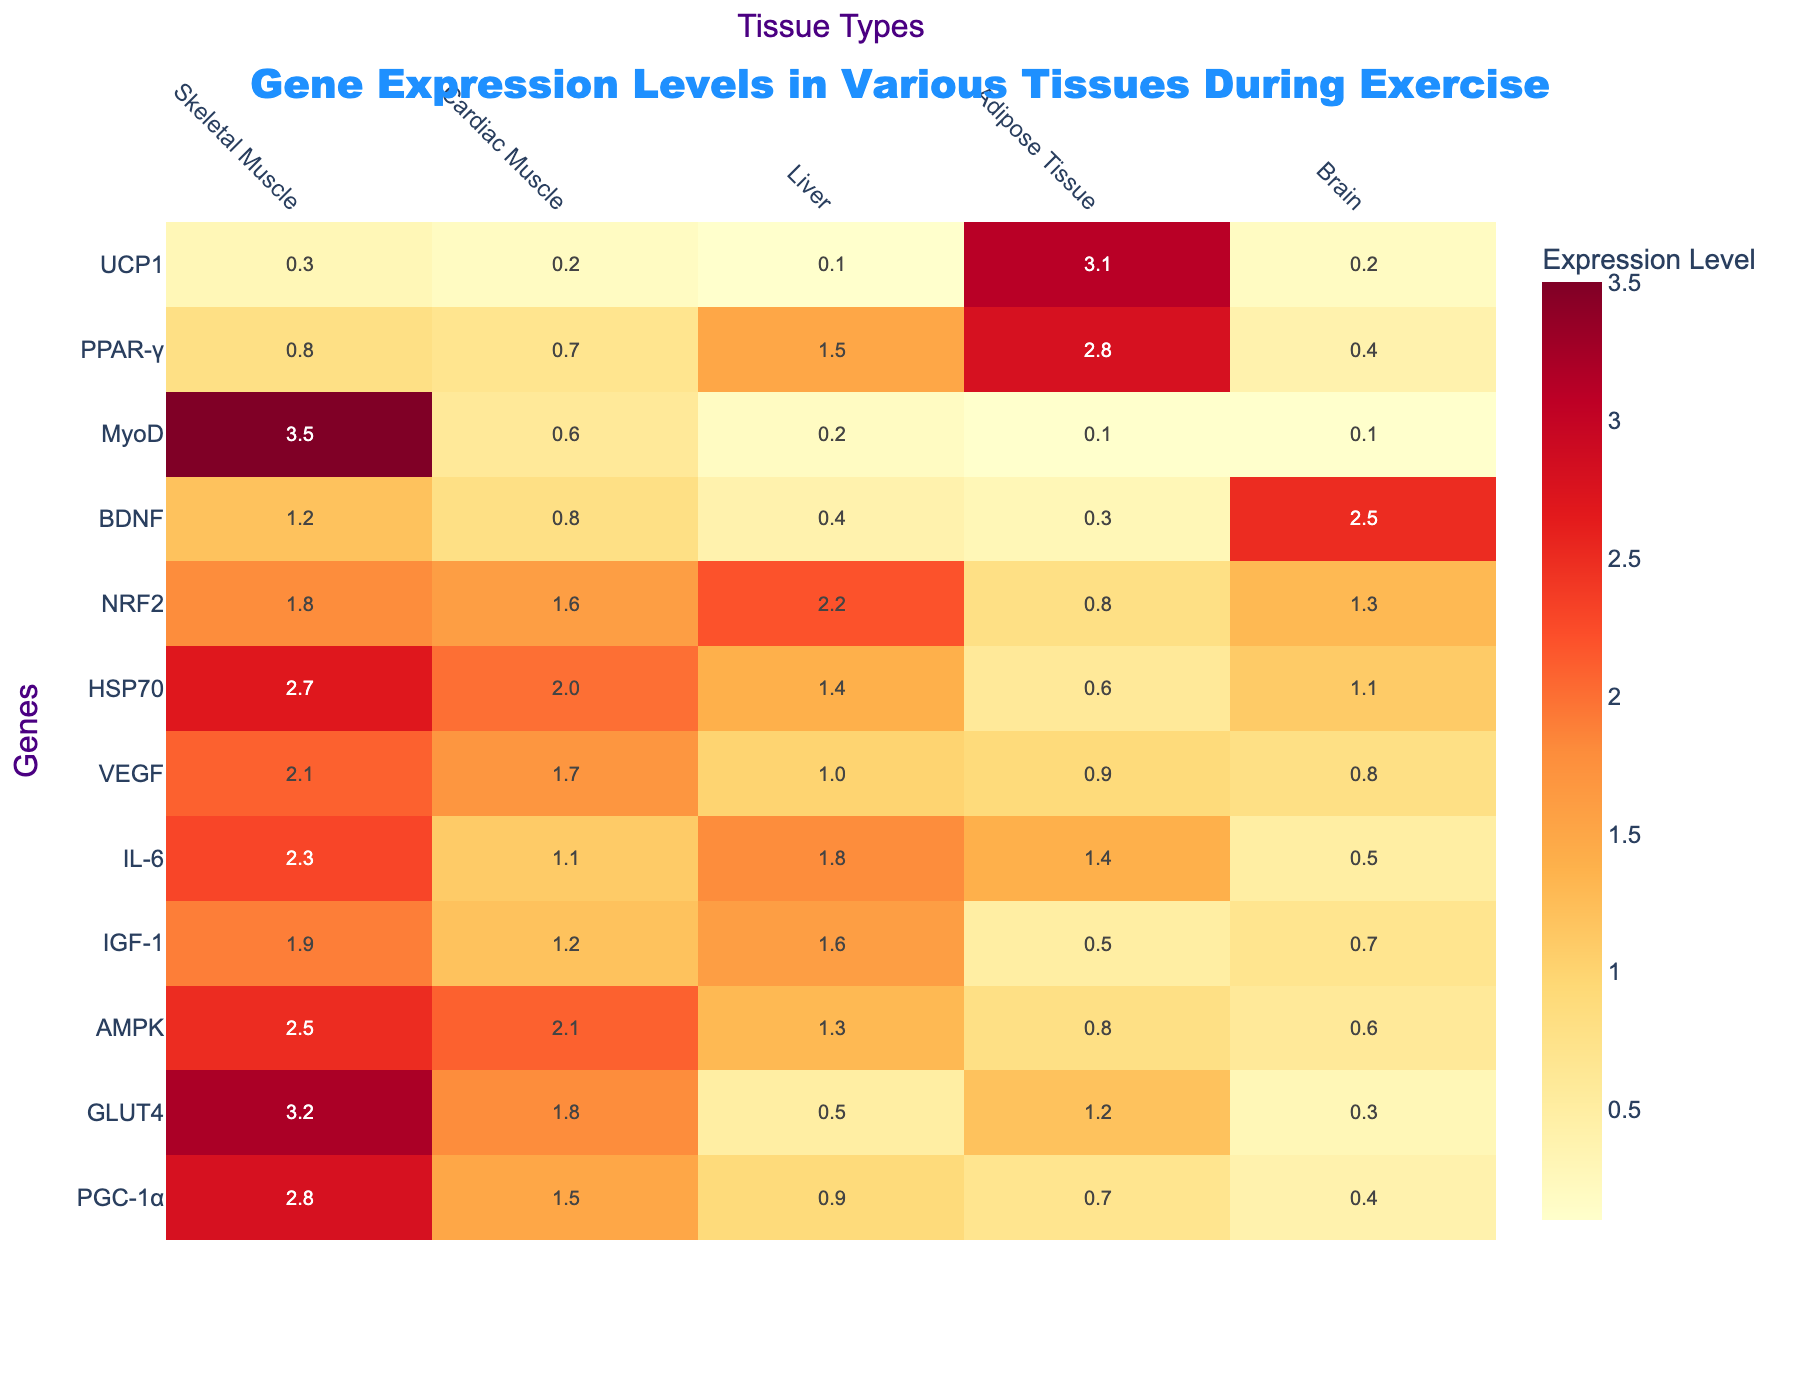What is the expression level of GLUT4 in Skeletal Muscle? The expression level of GLUT4 in Skeletal Muscle is directly taken from the table, where it clearly lists the value under the Skeletal Muscle column for the GLUT4 row.
Answer: 3.2 Which tissue has the highest expression level of PGC-1α? By looking down the PGC-1α row in the table, we can see that Skeletal Muscle has the highest value at 2.8.
Answer: Skeletal Muscle What is the overall average expression level of IGF-1 across all tissue types presented? To find the average for IGF-1, we sum the expression levels across the tissues: 1.9 (Skeletal Muscle) + 1.2 (Cardiac Muscle) + 1.6 (Liver) + 0.5 (Adipose Tissue) + 0.7 (Brain) = 5.9. There are 5 tissues, so we calculate the average: 5.9 / 5 = 1.18.
Answer: 1.18 Is the expression level of AMPK higher in Cardiac Muscle than in Skeletal Muscle? Looking at the values for AMPK in both Skeletal Muscle (2.5) and Cardiac Muscle (2.1), we see that 2.5 is greater than 2.1, answering the question about whether AMPK is higher in Cardiac Muscle.
Answer: No What is the difference in expression levels of HSP70 between Skeletal Muscle and Brain? For this question, we first identify the expression level of HSP70 in Skeletal Muscle, which is 2.7, and in Brain, which is 1.1. We then compute the difference: 2.7 - 1.1 = 1.6.
Answer: 1.6 Which gene has the lowest expression in Liver tissue? By reviewing the Liver column and finding the lowest value among the listed genes, we see that UCP1 has the lowest expression level of 0.1.
Answer: UCP1 In which tissue type is BDNF expressed the most? To deduce this, we need to check the value of BDNF across all tissue types. The values show Brain has the highest level of 2.5 among the others, so BDNF is most expressed in Brain.
Answer: Brain What is the sum of expression levels for PPAR-γ across all tissues? First, let's note down the values of PPAR-γ: 0.8 (Skeletal Muscle) + 0.7 (Cardiac Muscle) + 1.5 (Liver) + 2.8 (Adipose Tissue) + 0.4 (Brain) = 6.2. Thus, the total is 6.2.
Answer: 6.2 Is the expression level of VEGF in Cardiac Muscle greater than that in Adipose Tissue? The values show that VEGF is expressed at 1.7 in Cardiac Muscle and 0.9 in Adipose Tissue, which confirms that 1.7 is indeed greater than 0.9.
Answer: Yes What is the average expression level of BDNF and PPAR-γ combined across all tissue types? The values for BDNF are: 1.2 (Skeletal Muscle) + 0.8 (Cardiac Muscle) + 0.4 (Liver) + 0.3 (Adipose Tissue) + 2.5 (Brain) = 5.2. For PPAR-γ, they are: 0.8 (Skeletal Muscle) + 0.7 (Cardiac Muscle) + 1.5 (Liver) + 2.8 (Adipose Tissue) + 0.4 (Brain) = 6.2. Combining these totals gives us 5.2 + 6.2 = 11.4. The average across the 10 values (5 for BDNF and 5 for PPAR-γ) is 11.4 / 10 = 1.14.
Answer: 1.14 